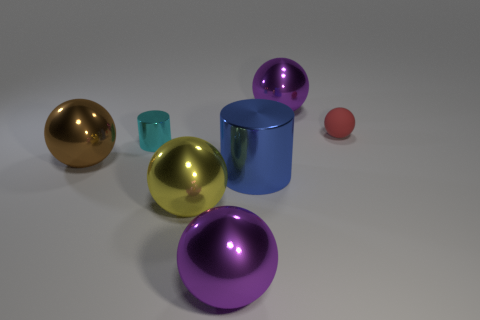Subtract all yellow metallic balls. How many balls are left? 4 Subtract all red spheres. How many spheres are left? 4 Subtract all gray balls. Subtract all brown cubes. How many balls are left? 5 Add 2 small red matte blocks. How many objects exist? 9 Subtract all spheres. How many objects are left? 2 Add 6 yellow matte things. How many yellow matte things exist? 6 Subtract 2 purple balls. How many objects are left? 5 Subtract all small cyan shiny cylinders. Subtract all big green metal objects. How many objects are left? 6 Add 4 purple things. How many purple things are left? 6 